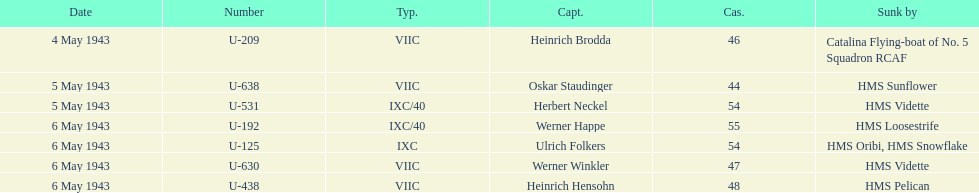Could you help me parse every detail presented in this table? {'header': ['Date', 'Number', 'Typ.', 'Capt.', 'Cas.', 'Sunk by'], 'rows': [['4 May 1943', 'U-209', 'VIIC', 'Heinrich Brodda', '46', 'Catalina Flying-boat of No. 5 Squadron RCAF'], ['5 May 1943', 'U-638', 'VIIC', 'Oskar Staudinger', '44', 'HMS Sunflower'], ['5 May 1943', 'U-531', 'IXC/40', 'Herbert Neckel', '54', 'HMS Vidette'], ['6 May 1943', 'U-192', 'IXC/40', 'Werner Happe', '55', 'HMS Loosestrife'], ['6 May 1943', 'U-125', 'IXC', 'Ulrich Folkers', '54', 'HMS Oribi, HMS Snowflake'], ['6 May 1943', 'U-630', 'VIIC', 'Werner Winkler', '47', 'HMS Vidette'], ['6 May 1943', 'U-438', 'VIIC', 'Heinrich Hensohn', '48', 'HMS Pelican']]} Which sunken u-boat had the most casualties U-192. 